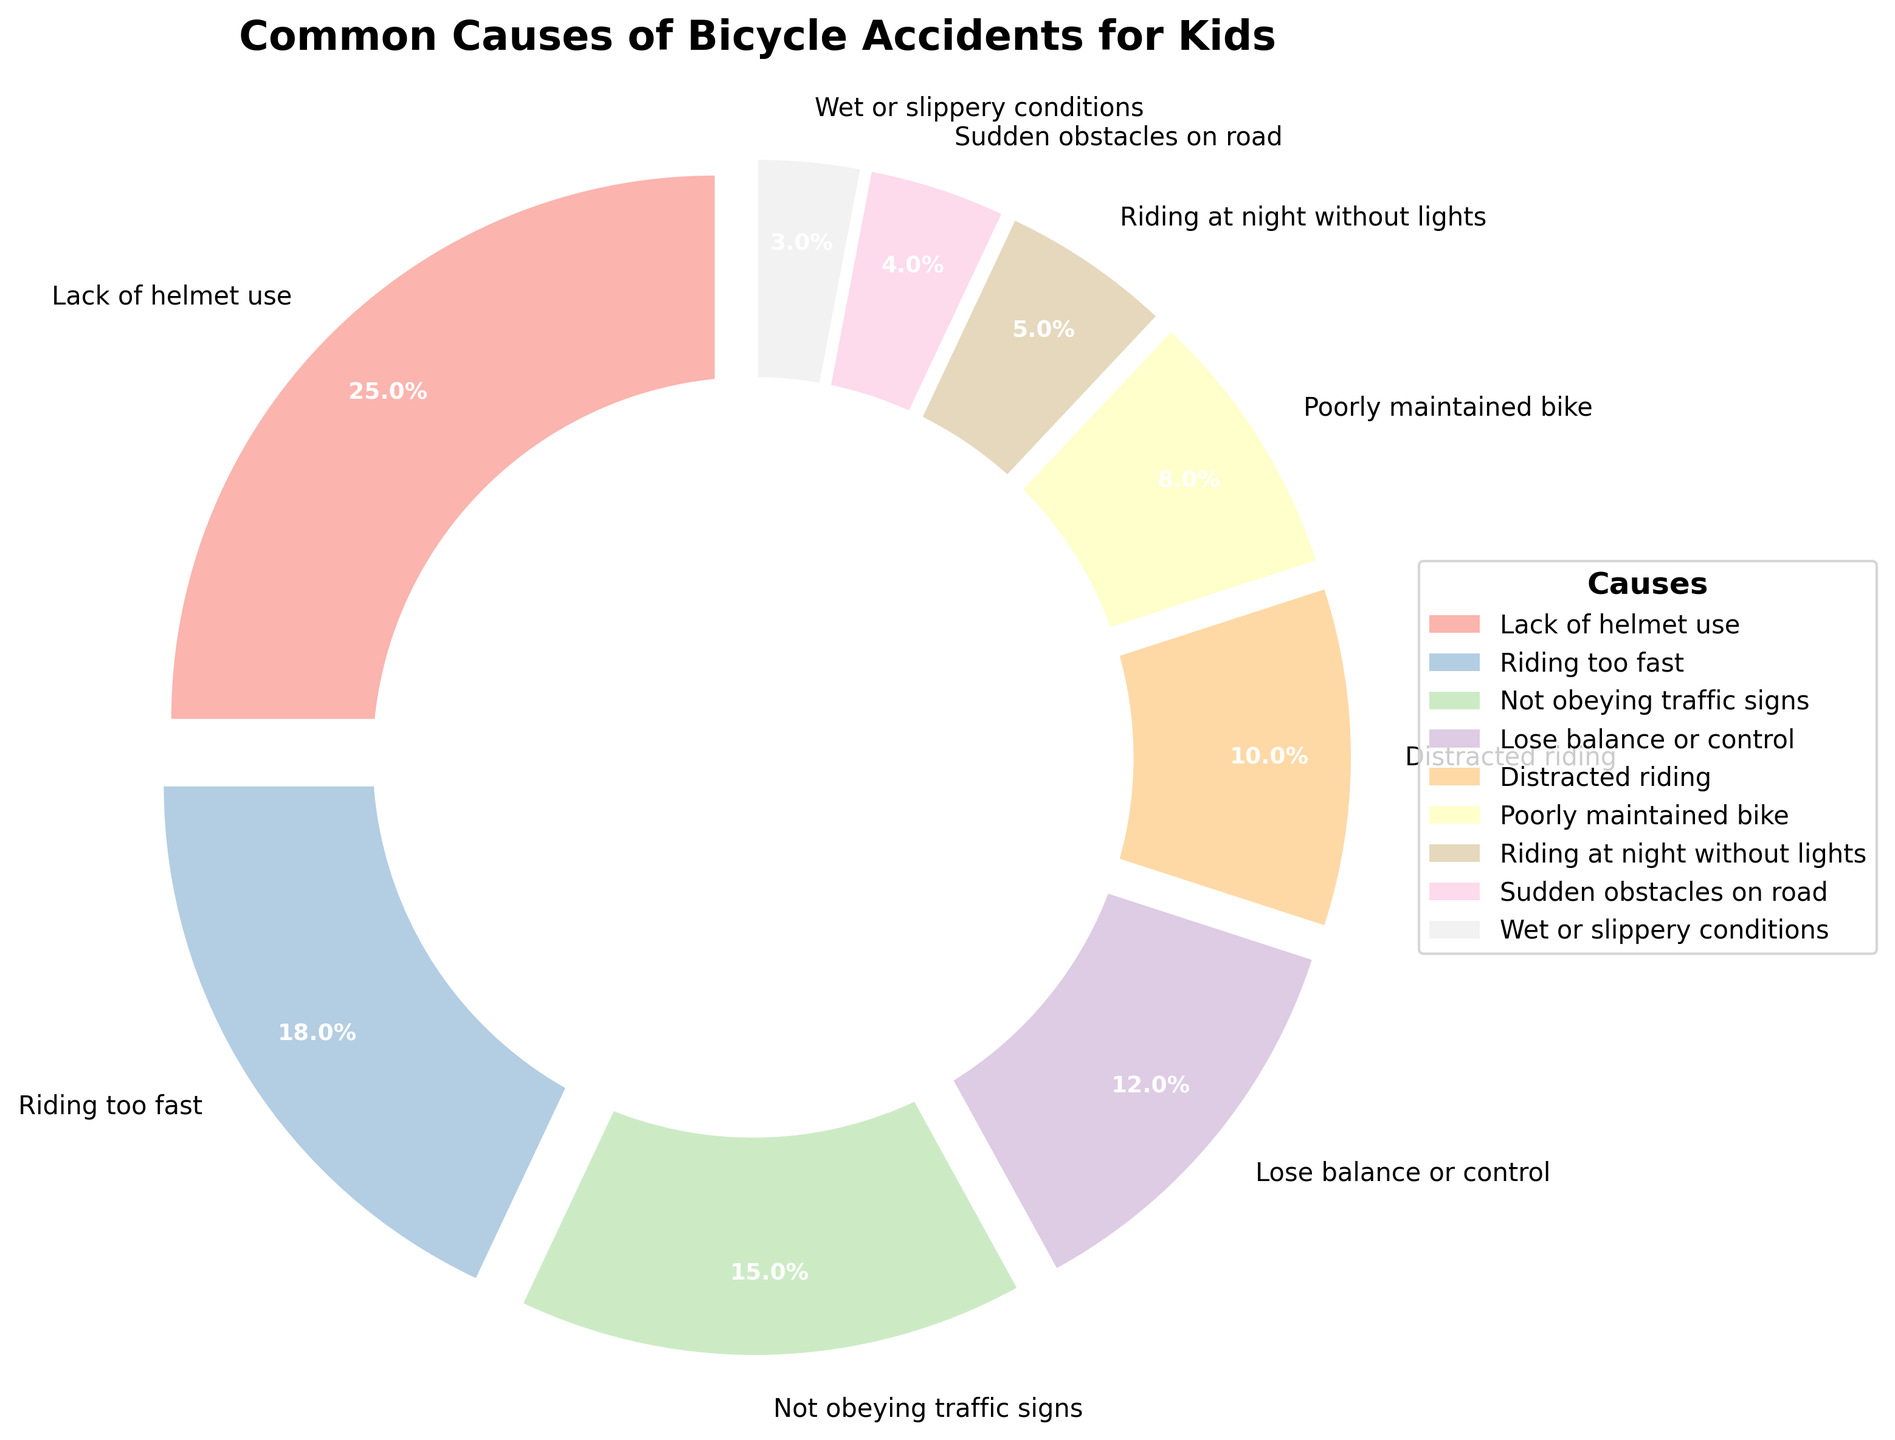What is the most common cause of bicycle accidents for kids? By looking at the chart, the largest segment corresponds to "Lack of helmet use" which has the highest percentage.
Answer: Lack of helmet use What is the combined percentage of accidents caused by riding too fast and not obeying traffic signs? Riding too fast accounts for 18% and not obeying traffic signs accounts for 15%, so the combined percentage is 18 + 15 = 33%.
Answer: 33% What cause has a slightly higher percentage than distracted riding? "Not obeying traffic signs" has a percentage of 15%, which is slightly higher than distracted riding at 10%.
Answer: Not obeying traffic signs Which cause is responsible for the least number of bicycle accidents? The smallest segment in the chart is for "Wet or slippery conditions" at 3%, indicating it is responsible for the least accidents.
Answer: Wet or slippery conditions Which is more prevalent, poorly maintained bikes or sudden obstacles on the road? Poorly maintained bikes have a higher percentage (8%) compared to sudden obstacles on the road (4%).
Answer: Poorly maintained bikes What is the total percentage of accidents caused by lack of helmet use, distracted riding, and poorly maintained bikes? Adding the percentages for lack of helmet use (25%), distracted riding (10%), and poorly maintained bikes (8%) gives 25 + 10 + 8 = 43%.
Answer: 43% What fraction of bicycle accidents is due to riding at night without lights? The percentage of accidents due to riding at night without lights is 5%, which corresponds to 5/100 or 1/20 as a fraction.
Answer: 1/20 How does the percentage of accidents due to losing balance or control compare to riding at night without lights? Losing balance or control accounts for 12%, which is higher than the 5% for riding at night without lights.
Answer: Losing balance or control is higher What percentage of accidents are due to causes related to bike condition (poorly maintained bike and wet or slippery conditions)? Summing the percentages for poorly maintained bike (8%) and wet or slippery conditions (3%) gives 8 + 3 = 11%.
Answer: 11% How much more common is the cause of riding too fast compared to wet or slippery conditions? Riding too fast accounts for 18% of accidents while wet or slippery conditions account for 3%, so it is 18 - 3 = 15% more common.
Answer: 15% 